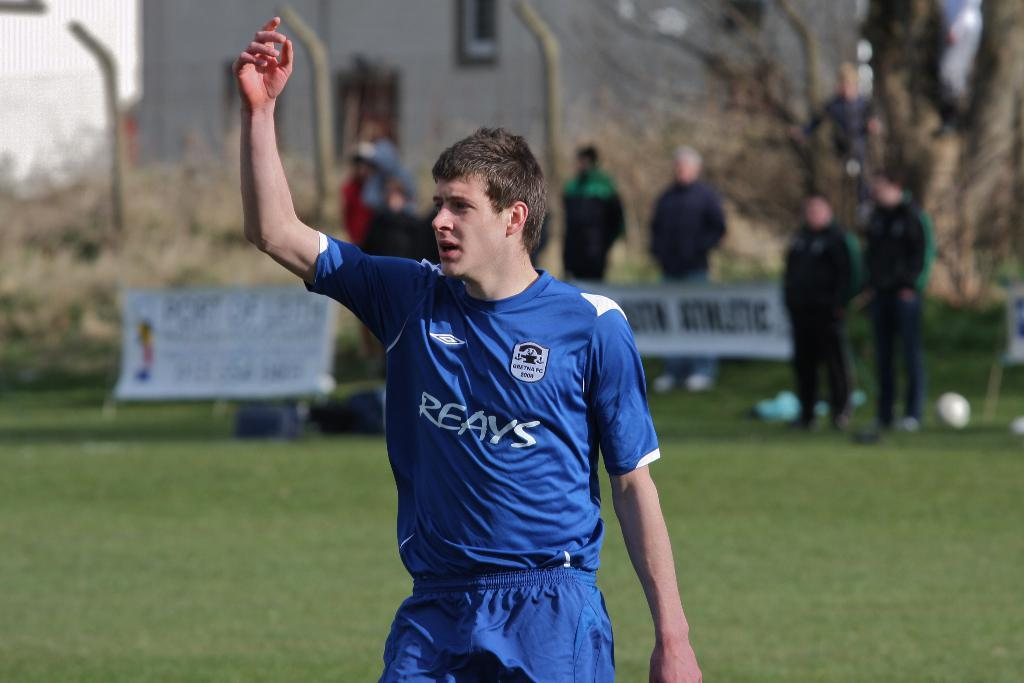<image>
Share a concise interpretation of the image provided. Male sports player in a Reays blue jersey 